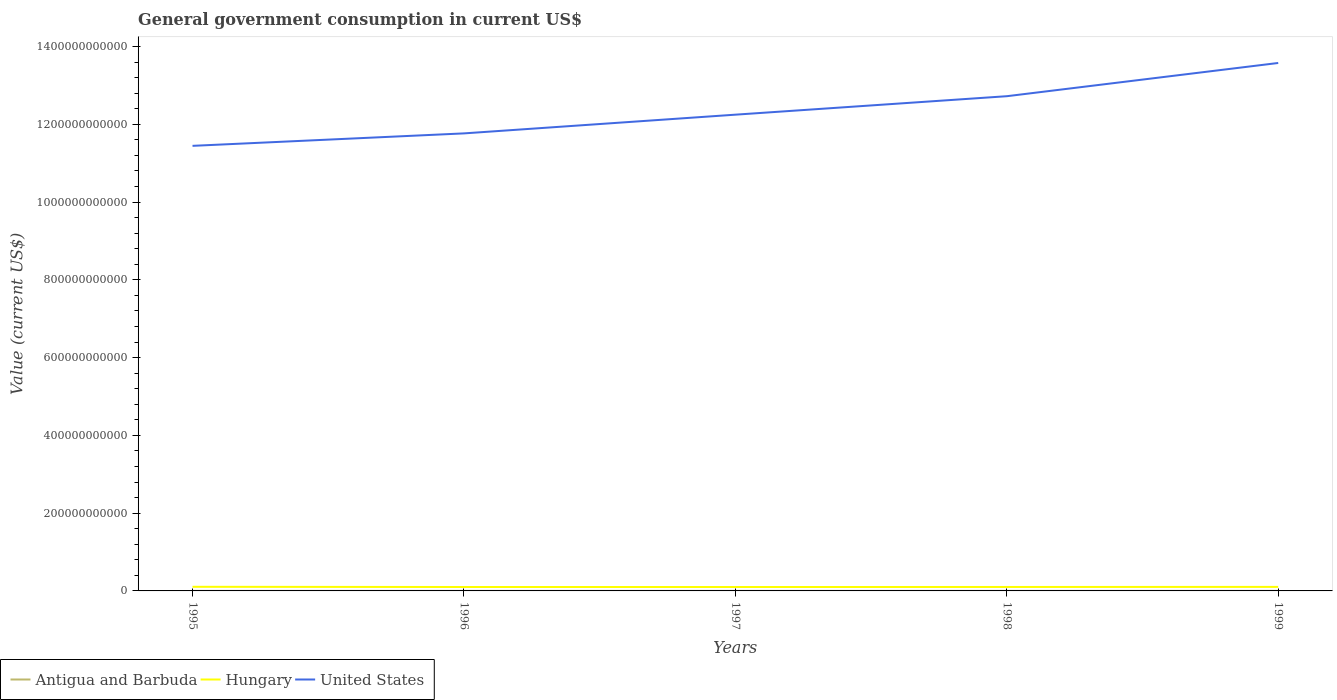Is the number of lines equal to the number of legend labels?
Your response must be concise. Yes. Across all years, what is the maximum government conusmption in Antigua and Barbuda?
Your response must be concise. 1.07e+08. What is the total government conusmption in Hungary in the graph?
Offer a very short reply. 5.74e+08. What is the difference between the highest and the second highest government conusmption in Antigua and Barbuda?
Ensure brevity in your answer.  3.96e+07. What is the difference between the highest and the lowest government conusmption in Antigua and Barbuda?
Offer a very short reply. 2. How many lines are there?
Offer a terse response. 3. How many years are there in the graph?
Provide a succinct answer. 5. What is the difference between two consecutive major ticks on the Y-axis?
Offer a very short reply. 2.00e+11. Are the values on the major ticks of Y-axis written in scientific E-notation?
Ensure brevity in your answer.  No. Does the graph contain grids?
Ensure brevity in your answer.  No. How many legend labels are there?
Keep it short and to the point. 3. How are the legend labels stacked?
Ensure brevity in your answer.  Horizontal. What is the title of the graph?
Keep it short and to the point. General government consumption in current US$. What is the label or title of the X-axis?
Ensure brevity in your answer.  Years. What is the label or title of the Y-axis?
Provide a short and direct response. Value (current US$). What is the Value (current US$) of Antigua and Barbuda in 1995?
Offer a very short reply. 1.07e+08. What is the Value (current US$) of Hungary in 1995?
Provide a succinct answer. 1.06e+1. What is the Value (current US$) in United States in 1995?
Provide a short and direct response. 1.14e+12. What is the Value (current US$) in Antigua and Barbuda in 1996?
Your answer should be compact. 1.14e+08. What is the Value (current US$) in Hungary in 1996?
Provide a succinct answer. 1.01e+1. What is the Value (current US$) of United States in 1996?
Offer a very short reply. 1.18e+12. What is the Value (current US$) in Antigua and Barbuda in 1997?
Offer a terse response. 1.18e+08. What is the Value (current US$) in Hungary in 1997?
Your answer should be very brief. 1.00e+1. What is the Value (current US$) of United States in 1997?
Your response must be concise. 1.22e+12. What is the Value (current US$) of Antigua and Barbuda in 1998?
Make the answer very short. 1.35e+08. What is the Value (current US$) in Hungary in 1998?
Provide a succinct answer. 1.02e+1. What is the Value (current US$) of United States in 1998?
Offer a very short reply. 1.27e+12. What is the Value (current US$) of Antigua and Barbuda in 1999?
Your answer should be compact. 1.47e+08. What is the Value (current US$) in Hungary in 1999?
Your answer should be very brief. 1.04e+1. What is the Value (current US$) in United States in 1999?
Provide a succinct answer. 1.36e+12. Across all years, what is the maximum Value (current US$) in Antigua and Barbuda?
Provide a short and direct response. 1.47e+08. Across all years, what is the maximum Value (current US$) of Hungary?
Make the answer very short. 1.06e+1. Across all years, what is the maximum Value (current US$) in United States?
Keep it short and to the point. 1.36e+12. Across all years, what is the minimum Value (current US$) of Antigua and Barbuda?
Your answer should be very brief. 1.07e+08. Across all years, what is the minimum Value (current US$) in Hungary?
Offer a terse response. 1.00e+1. Across all years, what is the minimum Value (current US$) in United States?
Your answer should be compact. 1.14e+12. What is the total Value (current US$) of Antigua and Barbuda in the graph?
Provide a succinct answer. 6.21e+08. What is the total Value (current US$) of Hungary in the graph?
Make the answer very short. 5.12e+1. What is the total Value (current US$) of United States in the graph?
Give a very brief answer. 6.18e+12. What is the difference between the Value (current US$) of Antigua and Barbuda in 1995 and that in 1996?
Offer a very short reply. -6.78e+06. What is the difference between the Value (current US$) in Hungary in 1995 and that in 1996?
Offer a terse response. 5.27e+08. What is the difference between the Value (current US$) of United States in 1995 and that in 1996?
Your answer should be compact. -3.20e+1. What is the difference between the Value (current US$) in Antigua and Barbuda in 1995 and that in 1997?
Make the answer very short. -1.06e+07. What is the difference between the Value (current US$) of Hungary in 1995 and that in 1997?
Make the answer very short. 5.74e+08. What is the difference between the Value (current US$) in United States in 1995 and that in 1997?
Your answer should be very brief. -8.01e+1. What is the difference between the Value (current US$) of Antigua and Barbuda in 1995 and that in 1998?
Make the answer very short. -2.79e+07. What is the difference between the Value (current US$) in Hungary in 1995 and that in 1998?
Make the answer very short. 4.40e+08. What is the difference between the Value (current US$) of United States in 1995 and that in 1998?
Provide a succinct answer. -1.28e+11. What is the difference between the Value (current US$) of Antigua and Barbuda in 1995 and that in 1999?
Provide a short and direct response. -3.96e+07. What is the difference between the Value (current US$) of Hungary in 1995 and that in 1999?
Give a very brief answer. 2.38e+08. What is the difference between the Value (current US$) of United States in 1995 and that in 1999?
Keep it short and to the point. -2.13e+11. What is the difference between the Value (current US$) of Antigua and Barbuda in 1996 and that in 1997?
Offer a terse response. -3.85e+06. What is the difference between the Value (current US$) of Hungary in 1996 and that in 1997?
Offer a very short reply. 4.67e+07. What is the difference between the Value (current US$) in United States in 1996 and that in 1997?
Give a very brief answer. -4.81e+1. What is the difference between the Value (current US$) of Antigua and Barbuda in 1996 and that in 1998?
Make the answer very short. -2.12e+07. What is the difference between the Value (current US$) of Hungary in 1996 and that in 1998?
Keep it short and to the point. -8.72e+07. What is the difference between the Value (current US$) in United States in 1996 and that in 1998?
Your answer should be compact. -9.56e+1. What is the difference between the Value (current US$) in Antigua and Barbuda in 1996 and that in 1999?
Your answer should be compact. -3.29e+07. What is the difference between the Value (current US$) in Hungary in 1996 and that in 1999?
Provide a succinct answer. -2.89e+08. What is the difference between the Value (current US$) in United States in 1996 and that in 1999?
Provide a short and direct response. -1.81e+11. What is the difference between the Value (current US$) of Antigua and Barbuda in 1997 and that in 1998?
Provide a succinct answer. -1.73e+07. What is the difference between the Value (current US$) of Hungary in 1997 and that in 1998?
Make the answer very short. -1.34e+08. What is the difference between the Value (current US$) of United States in 1997 and that in 1998?
Ensure brevity in your answer.  -4.75e+1. What is the difference between the Value (current US$) in Antigua and Barbuda in 1997 and that in 1999?
Ensure brevity in your answer.  -2.90e+07. What is the difference between the Value (current US$) in Hungary in 1997 and that in 1999?
Ensure brevity in your answer.  -3.36e+08. What is the difference between the Value (current US$) in United States in 1997 and that in 1999?
Ensure brevity in your answer.  -1.33e+11. What is the difference between the Value (current US$) in Antigua and Barbuda in 1998 and that in 1999?
Provide a short and direct response. -1.17e+07. What is the difference between the Value (current US$) in Hungary in 1998 and that in 1999?
Ensure brevity in your answer.  -2.02e+08. What is the difference between the Value (current US$) of United States in 1998 and that in 1999?
Offer a terse response. -8.55e+1. What is the difference between the Value (current US$) of Antigua and Barbuda in 1995 and the Value (current US$) of Hungary in 1996?
Provide a short and direct response. -9.97e+09. What is the difference between the Value (current US$) in Antigua and Barbuda in 1995 and the Value (current US$) in United States in 1996?
Your answer should be compact. -1.18e+12. What is the difference between the Value (current US$) in Hungary in 1995 and the Value (current US$) in United States in 1996?
Offer a terse response. -1.17e+12. What is the difference between the Value (current US$) in Antigua and Barbuda in 1995 and the Value (current US$) in Hungary in 1997?
Offer a terse response. -9.92e+09. What is the difference between the Value (current US$) of Antigua and Barbuda in 1995 and the Value (current US$) of United States in 1997?
Provide a succinct answer. -1.22e+12. What is the difference between the Value (current US$) of Hungary in 1995 and the Value (current US$) of United States in 1997?
Provide a succinct answer. -1.21e+12. What is the difference between the Value (current US$) of Antigua and Barbuda in 1995 and the Value (current US$) of Hungary in 1998?
Make the answer very short. -1.01e+1. What is the difference between the Value (current US$) of Antigua and Barbuda in 1995 and the Value (current US$) of United States in 1998?
Provide a succinct answer. -1.27e+12. What is the difference between the Value (current US$) in Hungary in 1995 and the Value (current US$) in United States in 1998?
Offer a terse response. -1.26e+12. What is the difference between the Value (current US$) of Antigua and Barbuda in 1995 and the Value (current US$) of Hungary in 1999?
Your response must be concise. -1.03e+1. What is the difference between the Value (current US$) of Antigua and Barbuda in 1995 and the Value (current US$) of United States in 1999?
Offer a terse response. -1.36e+12. What is the difference between the Value (current US$) of Hungary in 1995 and the Value (current US$) of United States in 1999?
Keep it short and to the point. -1.35e+12. What is the difference between the Value (current US$) of Antigua and Barbuda in 1996 and the Value (current US$) of Hungary in 1997?
Ensure brevity in your answer.  -9.91e+09. What is the difference between the Value (current US$) of Antigua and Barbuda in 1996 and the Value (current US$) of United States in 1997?
Offer a terse response. -1.22e+12. What is the difference between the Value (current US$) in Hungary in 1996 and the Value (current US$) in United States in 1997?
Your response must be concise. -1.21e+12. What is the difference between the Value (current US$) of Antigua and Barbuda in 1996 and the Value (current US$) of Hungary in 1998?
Offer a terse response. -1.00e+1. What is the difference between the Value (current US$) in Antigua and Barbuda in 1996 and the Value (current US$) in United States in 1998?
Make the answer very short. -1.27e+12. What is the difference between the Value (current US$) of Hungary in 1996 and the Value (current US$) of United States in 1998?
Provide a succinct answer. -1.26e+12. What is the difference between the Value (current US$) in Antigua and Barbuda in 1996 and the Value (current US$) in Hungary in 1999?
Offer a terse response. -1.02e+1. What is the difference between the Value (current US$) in Antigua and Barbuda in 1996 and the Value (current US$) in United States in 1999?
Give a very brief answer. -1.36e+12. What is the difference between the Value (current US$) of Hungary in 1996 and the Value (current US$) of United States in 1999?
Your answer should be compact. -1.35e+12. What is the difference between the Value (current US$) in Antigua and Barbuda in 1997 and the Value (current US$) in Hungary in 1998?
Provide a succinct answer. -1.00e+1. What is the difference between the Value (current US$) in Antigua and Barbuda in 1997 and the Value (current US$) in United States in 1998?
Ensure brevity in your answer.  -1.27e+12. What is the difference between the Value (current US$) in Hungary in 1997 and the Value (current US$) in United States in 1998?
Your answer should be compact. -1.26e+12. What is the difference between the Value (current US$) of Antigua and Barbuda in 1997 and the Value (current US$) of Hungary in 1999?
Make the answer very short. -1.02e+1. What is the difference between the Value (current US$) of Antigua and Barbuda in 1997 and the Value (current US$) of United States in 1999?
Provide a short and direct response. -1.36e+12. What is the difference between the Value (current US$) in Hungary in 1997 and the Value (current US$) in United States in 1999?
Offer a very short reply. -1.35e+12. What is the difference between the Value (current US$) in Antigua and Barbuda in 1998 and the Value (current US$) in Hungary in 1999?
Your response must be concise. -1.02e+1. What is the difference between the Value (current US$) in Antigua and Barbuda in 1998 and the Value (current US$) in United States in 1999?
Ensure brevity in your answer.  -1.36e+12. What is the difference between the Value (current US$) in Hungary in 1998 and the Value (current US$) in United States in 1999?
Make the answer very short. -1.35e+12. What is the average Value (current US$) in Antigua and Barbuda per year?
Make the answer very short. 1.24e+08. What is the average Value (current US$) of Hungary per year?
Make the answer very short. 1.02e+1. What is the average Value (current US$) of United States per year?
Give a very brief answer. 1.24e+12. In the year 1995, what is the difference between the Value (current US$) of Antigua and Barbuda and Value (current US$) of Hungary?
Your answer should be very brief. -1.05e+1. In the year 1995, what is the difference between the Value (current US$) in Antigua and Barbuda and Value (current US$) in United States?
Make the answer very short. -1.14e+12. In the year 1995, what is the difference between the Value (current US$) of Hungary and Value (current US$) of United States?
Provide a short and direct response. -1.13e+12. In the year 1996, what is the difference between the Value (current US$) of Antigua and Barbuda and Value (current US$) of Hungary?
Give a very brief answer. -9.96e+09. In the year 1996, what is the difference between the Value (current US$) of Antigua and Barbuda and Value (current US$) of United States?
Provide a short and direct response. -1.18e+12. In the year 1996, what is the difference between the Value (current US$) of Hungary and Value (current US$) of United States?
Offer a very short reply. -1.17e+12. In the year 1997, what is the difference between the Value (current US$) in Antigua and Barbuda and Value (current US$) in Hungary?
Ensure brevity in your answer.  -9.91e+09. In the year 1997, what is the difference between the Value (current US$) of Antigua and Barbuda and Value (current US$) of United States?
Ensure brevity in your answer.  -1.22e+12. In the year 1997, what is the difference between the Value (current US$) of Hungary and Value (current US$) of United States?
Provide a short and direct response. -1.21e+12. In the year 1998, what is the difference between the Value (current US$) of Antigua and Barbuda and Value (current US$) of Hungary?
Make the answer very short. -1.00e+1. In the year 1998, what is the difference between the Value (current US$) of Antigua and Barbuda and Value (current US$) of United States?
Ensure brevity in your answer.  -1.27e+12. In the year 1998, what is the difference between the Value (current US$) of Hungary and Value (current US$) of United States?
Ensure brevity in your answer.  -1.26e+12. In the year 1999, what is the difference between the Value (current US$) in Antigua and Barbuda and Value (current US$) in Hungary?
Your response must be concise. -1.02e+1. In the year 1999, what is the difference between the Value (current US$) of Antigua and Barbuda and Value (current US$) of United States?
Offer a very short reply. -1.36e+12. In the year 1999, what is the difference between the Value (current US$) in Hungary and Value (current US$) in United States?
Your answer should be compact. -1.35e+12. What is the ratio of the Value (current US$) in Antigua and Barbuda in 1995 to that in 1996?
Provide a succinct answer. 0.94. What is the ratio of the Value (current US$) in Hungary in 1995 to that in 1996?
Provide a succinct answer. 1.05. What is the ratio of the Value (current US$) in United States in 1995 to that in 1996?
Provide a succinct answer. 0.97. What is the ratio of the Value (current US$) in Antigua and Barbuda in 1995 to that in 1997?
Provide a short and direct response. 0.91. What is the ratio of the Value (current US$) in Hungary in 1995 to that in 1997?
Provide a short and direct response. 1.06. What is the ratio of the Value (current US$) of United States in 1995 to that in 1997?
Keep it short and to the point. 0.93. What is the ratio of the Value (current US$) in Antigua and Barbuda in 1995 to that in 1998?
Your answer should be very brief. 0.79. What is the ratio of the Value (current US$) in Hungary in 1995 to that in 1998?
Your answer should be compact. 1.04. What is the ratio of the Value (current US$) in United States in 1995 to that in 1998?
Offer a terse response. 0.9. What is the ratio of the Value (current US$) of Antigua and Barbuda in 1995 to that in 1999?
Your answer should be very brief. 0.73. What is the ratio of the Value (current US$) in Hungary in 1995 to that in 1999?
Provide a short and direct response. 1.02. What is the ratio of the Value (current US$) in United States in 1995 to that in 1999?
Your answer should be very brief. 0.84. What is the ratio of the Value (current US$) in Antigua and Barbuda in 1996 to that in 1997?
Make the answer very short. 0.97. What is the ratio of the Value (current US$) in Hungary in 1996 to that in 1997?
Your answer should be compact. 1. What is the ratio of the Value (current US$) in United States in 1996 to that in 1997?
Your answer should be very brief. 0.96. What is the ratio of the Value (current US$) in Antigua and Barbuda in 1996 to that in 1998?
Keep it short and to the point. 0.84. What is the ratio of the Value (current US$) of Hungary in 1996 to that in 1998?
Keep it short and to the point. 0.99. What is the ratio of the Value (current US$) in United States in 1996 to that in 1998?
Provide a succinct answer. 0.92. What is the ratio of the Value (current US$) of Antigua and Barbuda in 1996 to that in 1999?
Your answer should be very brief. 0.78. What is the ratio of the Value (current US$) in Hungary in 1996 to that in 1999?
Ensure brevity in your answer.  0.97. What is the ratio of the Value (current US$) in United States in 1996 to that in 1999?
Your response must be concise. 0.87. What is the ratio of the Value (current US$) in Antigua and Barbuda in 1997 to that in 1998?
Give a very brief answer. 0.87. What is the ratio of the Value (current US$) of United States in 1997 to that in 1998?
Provide a succinct answer. 0.96. What is the ratio of the Value (current US$) in Antigua and Barbuda in 1997 to that in 1999?
Offer a terse response. 0.8. What is the ratio of the Value (current US$) in Hungary in 1997 to that in 1999?
Offer a terse response. 0.97. What is the ratio of the Value (current US$) of United States in 1997 to that in 1999?
Give a very brief answer. 0.9. What is the ratio of the Value (current US$) of Antigua and Barbuda in 1998 to that in 1999?
Offer a terse response. 0.92. What is the ratio of the Value (current US$) in Hungary in 1998 to that in 1999?
Offer a terse response. 0.98. What is the ratio of the Value (current US$) of United States in 1998 to that in 1999?
Make the answer very short. 0.94. What is the difference between the highest and the second highest Value (current US$) in Antigua and Barbuda?
Ensure brevity in your answer.  1.17e+07. What is the difference between the highest and the second highest Value (current US$) in Hungary?
Ensure brevity in your answer.  2.38e+08. What is the difference between the highest and the second highest Value (current US$) in United States?
Offer a very short reply. 8.55e+1. What is the difference between the highest and the lowest Value (current US$) of Antigua and Barbuda?
Make the answer very short. 3.96e+07. What is the difference between the highest and the lowest Value (current US$) of Hungary?
Provide a succinct answer. 5.74e+08. What is the difference between the highest and the lowest Value (current US$) of United States?
Offer a very short reply. 2.13e+11. 